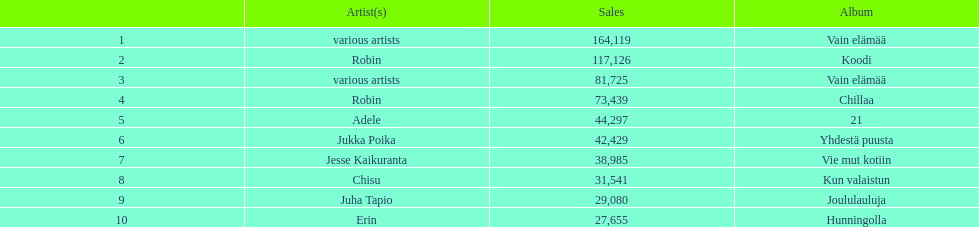Which album has the highest number of sales but doesn't have a designated artist? Vain elämää. 